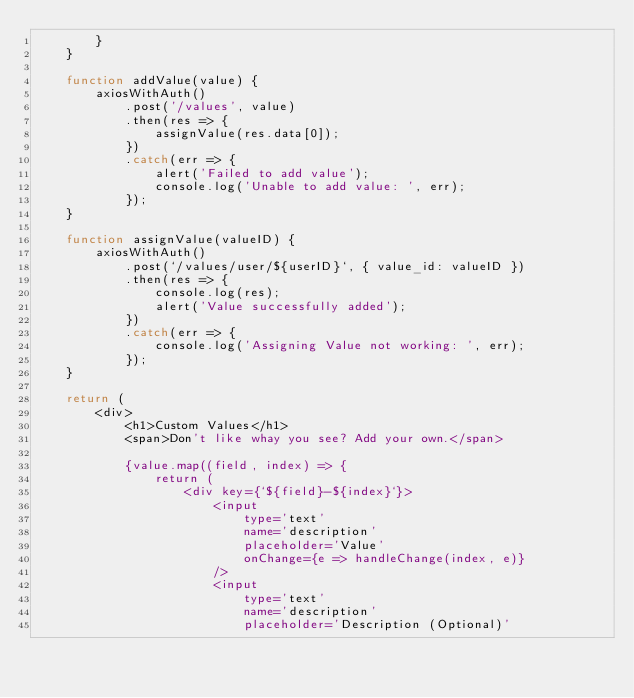Convert code to text. <code><loc_0><loc_0><loc_500><loc_500><_JavaScript_>        }
    }

    function addValue(value) {
        axiosWithAuth()
            .post('/values', value)
            .then(res => {
                assignValue(res.data[0]);
            })
            .catch(err => {
                alert('Failed to add value');
                console.log('Unable to add value: ', err);
            });
    }

    function assignValue(valueID) {
        axiosWithAuth()
            .post(`/values/user/${userID}`, { value_id: valueID })
            .then(res => {
                console.log(res);
                alert('Value successfully added');
            })
            .catch(err => {
                console.log('Assigning Value not working: ', err);
            });
    }

    return (
        <div>
            <h1>Custom Values</h1>
            <span>Don't like whay you see? Add your own.</span>

            {value.map((field, index) => {
                return (
                    <div key={`${field}-${index}`}>
                        <input
                            type='text'
                            name='description'
                            placeholder='Value'
                            onChange={e => handleChange(index, e)}
                        />
                        <input
                            type='text'
                            name='description'
                            placeholder='Description (Optional)'</code> 